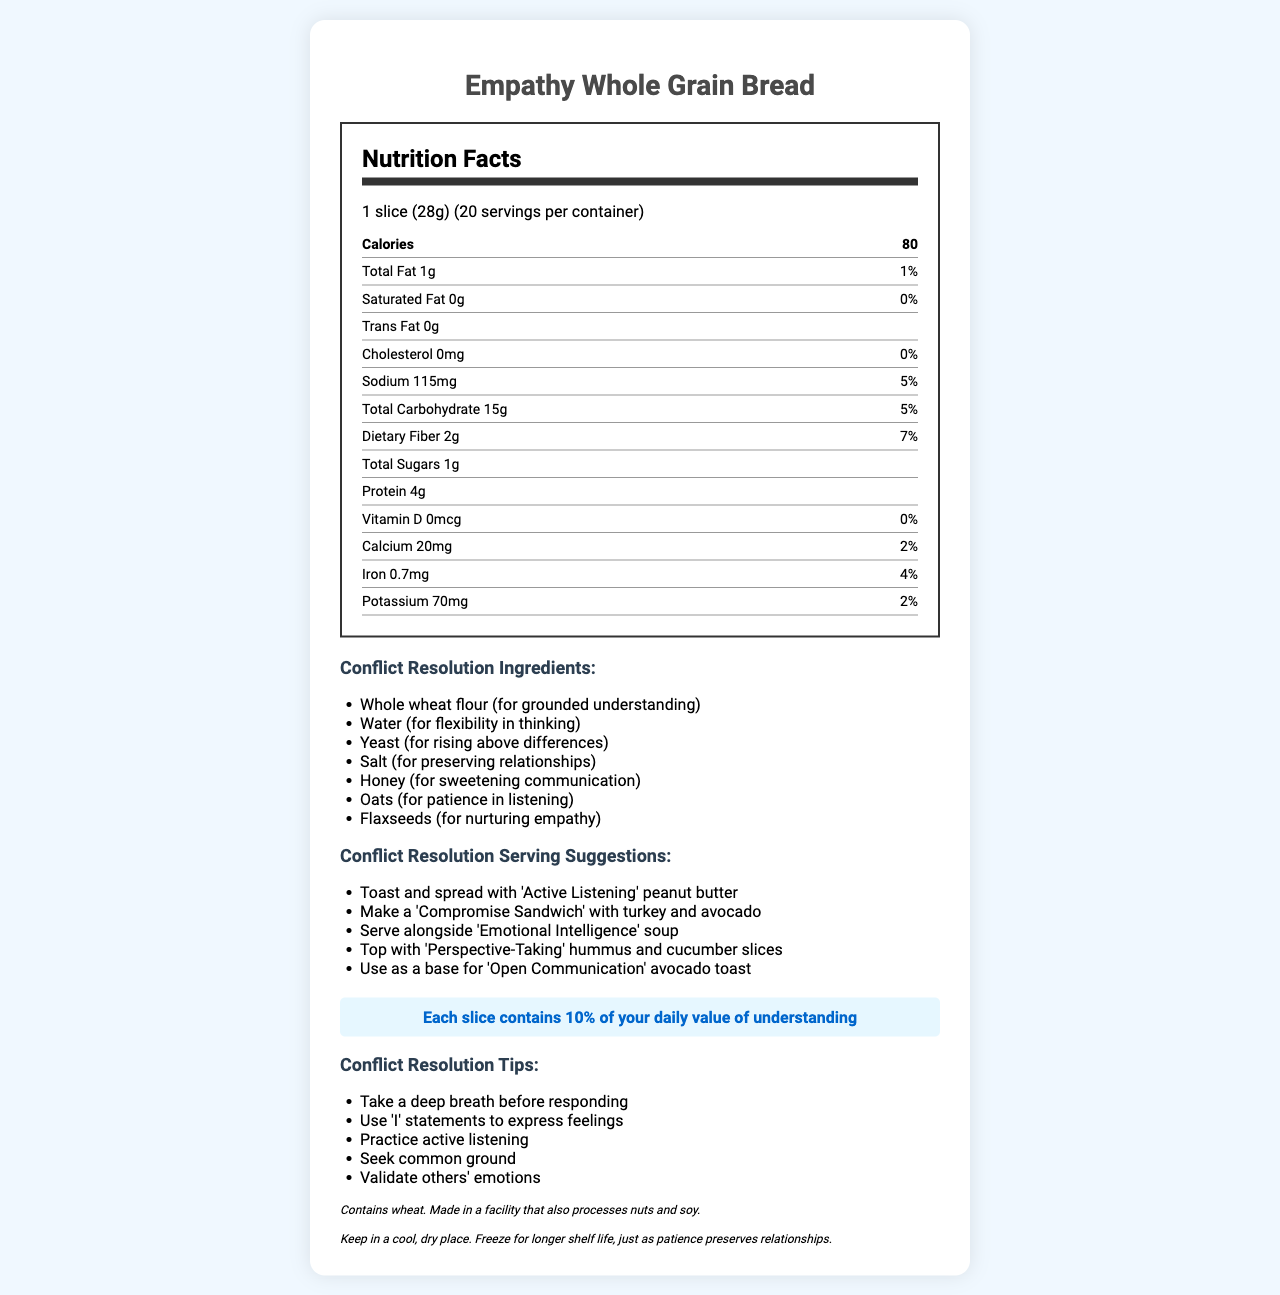what is the serving size? The serving size is stated as "1 slice (28g)" in the document.
Answer: 1 slice (28g) how many servings per container? The document specifies that there are 20 servings per container.
Answer: 20 how many calories are in one serving? The document mentions that each serving contains 80 calories.
Answer: 80 what is the amount of sodium per serving? The document lists the amount of sodium per serving as 115mg.
Answer: 115mg what is the % Daily Value of dietary fiber per serving? According to the document, the dietary fiber per serving has a % Daily Value of 7%.
Answer: 7% what are the "Conflict Resolution Ingredients"? The document provides a list of "Conflict Resolution Ingredients," which includes Whole wheat flour, Water, Yeast, Salt, Honey, Oats, and Flaxseeds.
Answer: Whole wheat flour, Water, Yeast, Salt, Honey, Oats, Flaxseeds what is one of the tips for conflict resolution? Among the listed tips, "Practice active listening" is one of the conflict resolution tips.
Answer: Practice active listening which is a suggested serving suggestion? A) Serve with cheese and ham B) Make a 'Compromise Sandwich' with turkey and avocado C) Top with tomato and basil The document includes "Make a 'Compromise Sandwich' with turkey and avocado" as one of the Conflict Resolution Serving Suggestions.
Answer: B) Make a 'Compromise Sandwich' with turkey and avocado which vitamin percentage is not present in the bread? A) Vitamin D B) Calcium C) Iron D) Potassium According to the document, the % Daily Value for Vitamin D is 0%.
Answer: A) Vitamin D does the nutrition label indicate trans fat content? The document specifies that the trans fat content is 0g per serving.
Answer: Yes describe the main idea of the document. The document primarily centers on Empathy Whole Grain Bread, presenting its nutritional facts, conflict resolution-themed ingredients, serving suggestions, and tips. It blends the concepts of nutritional education and conflict resolution, providing holistic information that combines physical and emotional well-being aspects.
Answer: The document provides nutritional information for Empathy Whole Grain Bread, along with unique features such as conflict resolution-themed ingredients, serving suggestions, and parenting teaching moments. The label emphasizes the importance of empathy and understanding in conflict resolution, integrating these themes into the bread's nutritional information, ingredient list, and serves as educational tools for parents. where is the bread made? The document does not provide information about the manufacturing location of the bread.
Answer: Cannot be determined what percentage of your daily value of understanding does each slice contain? The document highlights that each slice contains 10% of your daily value of understanding, listed under "empathy boost".
Answer: 10% 